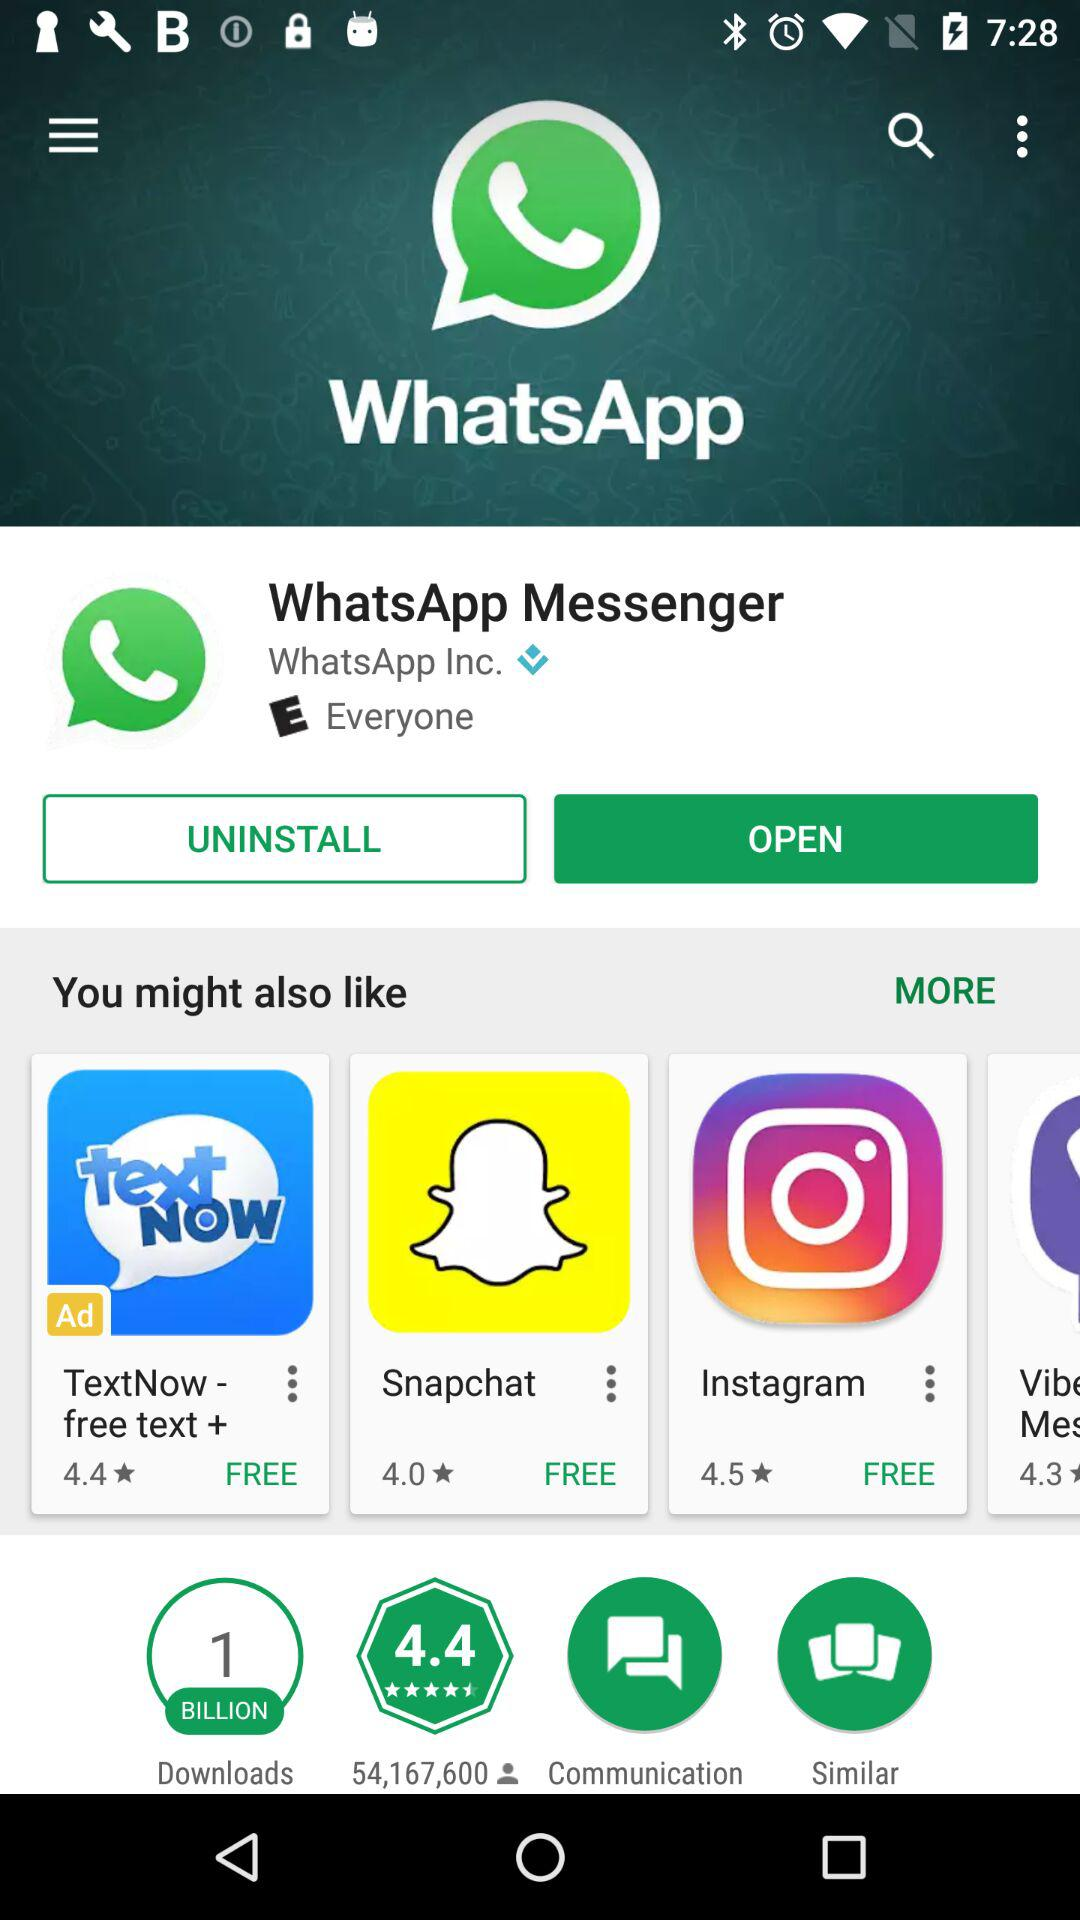What is the rating of the application "Snapchat"? The rating of the application "Snapchat" is 4.0. 